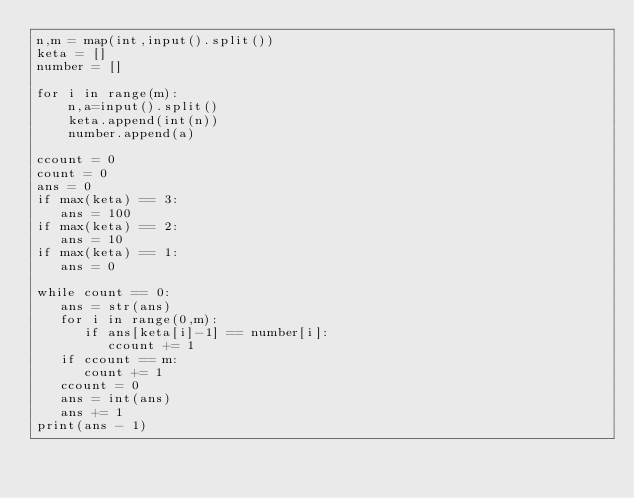<code> <loc_0><loc_0><loc_500><loc_500><_Python_>n,m = map(int,input().split())
keta = []
number = []

for i in range(m):
    n,a=input().split()
    keta.append(int(n))
    number.append(a)

ccount = 0
count = 0   
ans = 0
if max(keta) == 3:
   ans = 100
if max(keta) == 2:
   ans = 10
if max(keta) == 1:
   ans = 0

while count == 0:
   ans = str(ans)
   for i in range(0,m):
      if ans[keta[i]-1] == number[i]:
         ccount += 1
   if ccount == m:
      count += 1
   ccount = 0
   ans = int(ans)
   ans += 1
print(ans - 1)</code> 